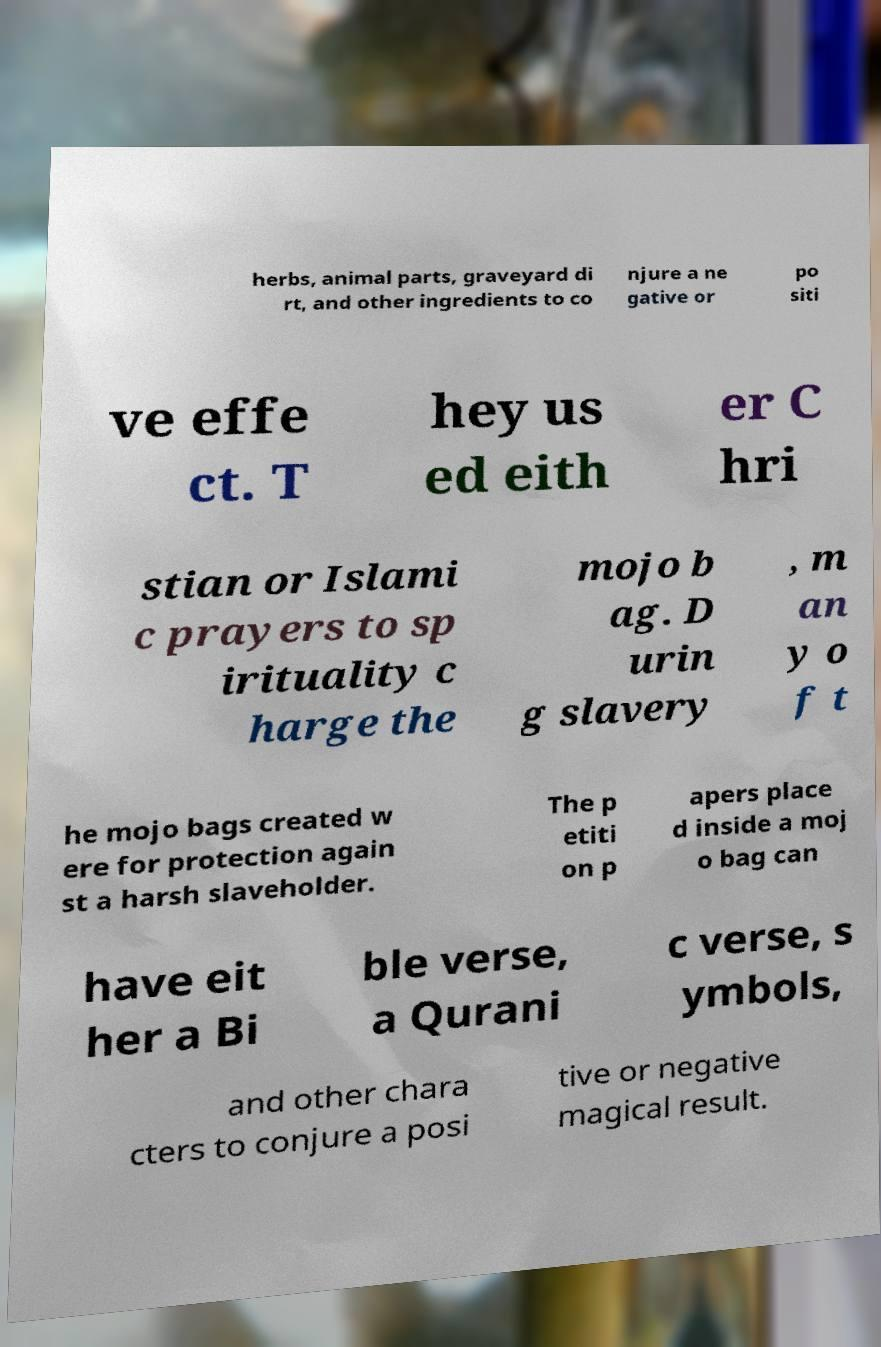What messages or text are displayed in this image? I need them in a readable, typed format. herbs, animal parts, graveyard di rt, and other ingredients to co njure a ne gative or po siti ve effe ct. T hey us ed eith er C hri stian or Islami c prayers to sp irituality c harge the mojo b ag. D urin g slavery , m an y o f t he mojo bags created w ere for protection again st a harsh slaveholder. The p etiti on p apers place d inside a moj o bag can have eit her a Bi ble verse, a Qurani c verse, s ymbols, and other chara cters to conjure a posi tive or negative magical result. 